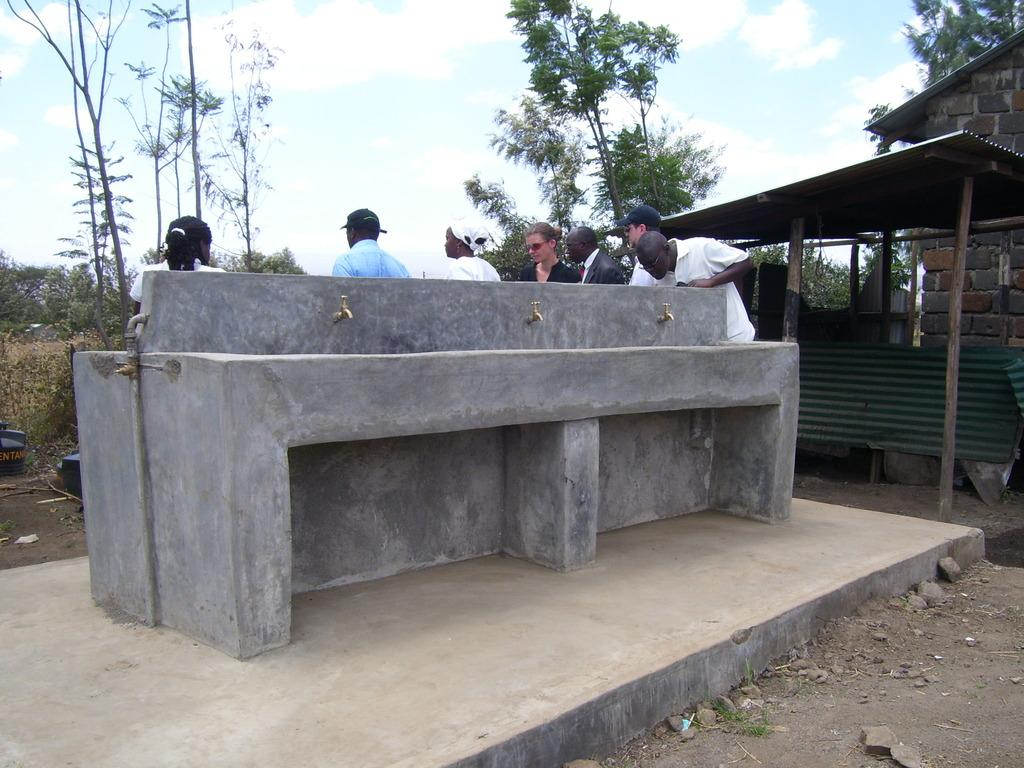How many persons are in the image? There are persons in the image. What can be seen in the image besides the persons? There is a pipeline, taps, a shed, walls built with cobblestones, trees, plants, the sky, and clouds in the image. Can you describe the walls in the image? The walls in the image are built with cobblestones. What type of vegetation is present in the image? There are trees and plants in the image. What is visible in the sky in the image? The sky is visible in the image, and there are clouds in the sky. Can you tell me how many rats are sitting on the pipeline in the image? There are no rats present in the image; the pipeline is the only object mentioned in the facts. What type of request is being made by the kitten in the image? There is no kitten present in the image, so no request can be observed. 